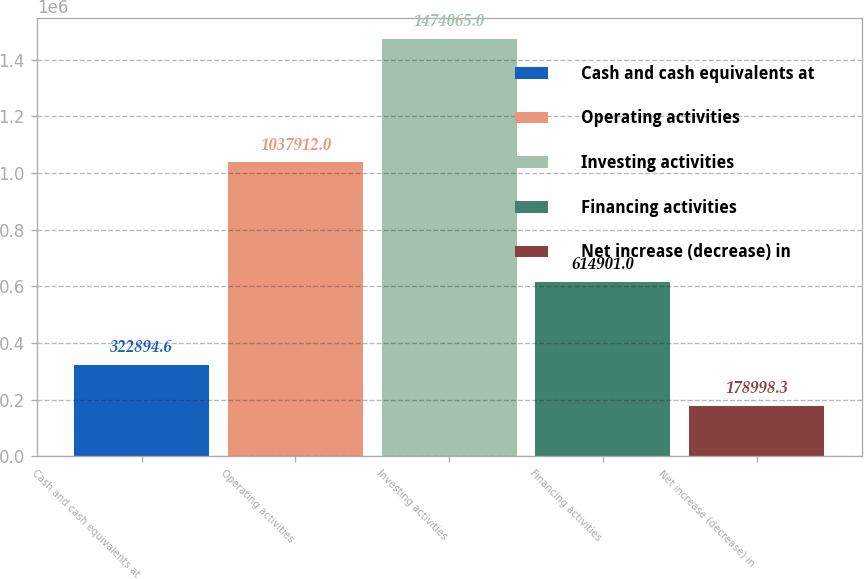Convert chart to OTSL. <chart><loc_0><loc_0><loc_500><loc_500><bar_chart><fcel>Cash and cash equivalents at<fcel>Operating activities<fcel>Investing activities<fcel>Financing activities<fcel>Net increase (decrease) in<nl><fcel>322895<fcel>1.03791e+06<fcel>1.47406e+06<fcel>614901<fcel>178998<nl></chart> 